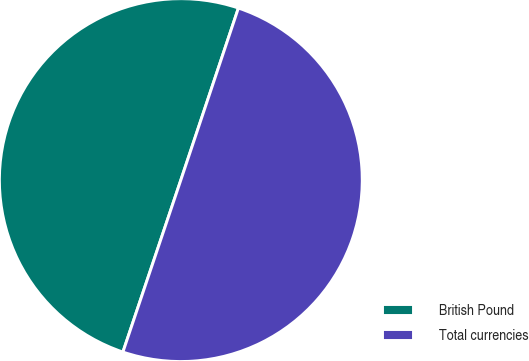Convert chart. <chart><loc_0><loc_0><loc_500><loc_500><pie_chart><fcel>British Pound<fcel>Total currencies<nl><fcel>49.97%<fcel>50.03%<nl></chart> 